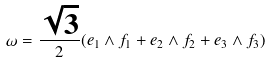<formula> <loc_0><loc_0><loc_500><loc_500>\omega = \frac { \sqrt { 3 } } { 2 } ( e _ { 1 } \wedge f _ { 1 } + e _ { 2 } \wedge f _ { 2 } + e _ { 3 } \wedge f _ { 3 } )</formula> 